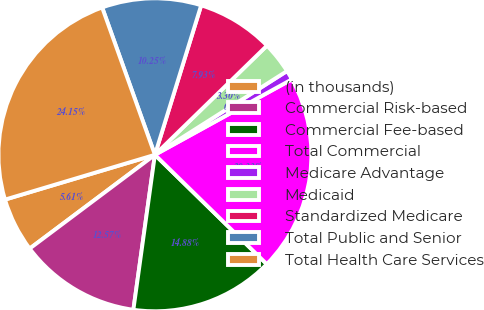Convert chart. <chart><loc_0><loc_0><loc_500><loc_500><pie_chart><fcel>(in thousands)<fcel>Commercial Risk-based<fcel>Commercial Fee-based<fcel>Total Commercial<fcel>Medicare Advantage<fcel>Medicaid<fcel>Standardized Medicare<fcel>Total Public and Senior<fcel>Total Health Care Services<nl><fcel>5.61%<fcel>12.57%<fcel>14.88%<fcel>20.33%<fcel>0.98%<fcel>3.3%<fcel>7.93%<fcel>10.25%<fcel>24.15%<nl></chart> 